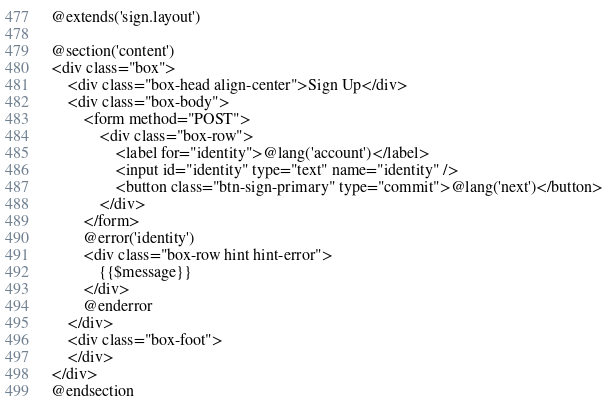Convert code to text. <code><loc_0><loc_0><loc_500><loc_500><_PHP_>@extends('sign.layout')

@section('content')
<div class="box">
    <div class="box-head align-center">Sign Up</div>
    <div class="box-body">
        <form method="POST">
            <div class="box-row">
                <label for="identity">@lang('account')</label>
                <input id="identity" type="text" name="identity" />
                <button class="btn-sign-primary" type="commit">@lang('next')</button>
            </div>
        </form>
        @error('identity')
        <div class="box-row hint hint-error">
            {{$message}}
        </div>
        @enderror
    </div>
    <div class="box-foot">
    </div>
</div>
@endsection</code> 